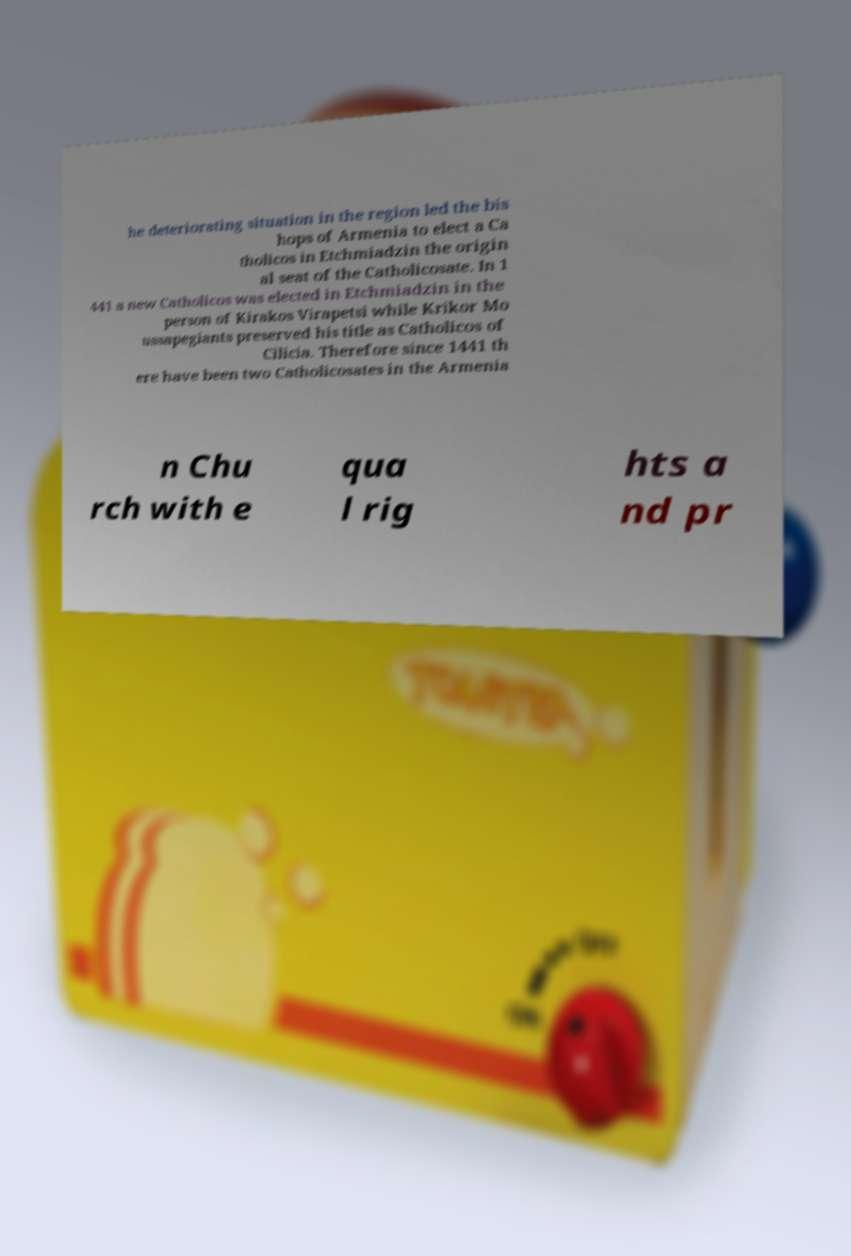Can you read and provide the text displayed in the image?This photo seems to have some interesting text. Can you extract and type it out for me? he deteriorating situation in the region led the bis hops of Armenia to elect a Ca tholicos in Etchmiadzin the origin al seat of the Catholicosate. In 1 441 a new Catholicos was elected in Etchmiadzin in the person of Kirakos Virapetsi while Krikor Mo ussapegiants preserved his title as Catholicos of Cilicia. Therefore since 1441 th ere have been two Catholicosates in the Armenia n Chu rch with e qua l rig hts a nd pr 